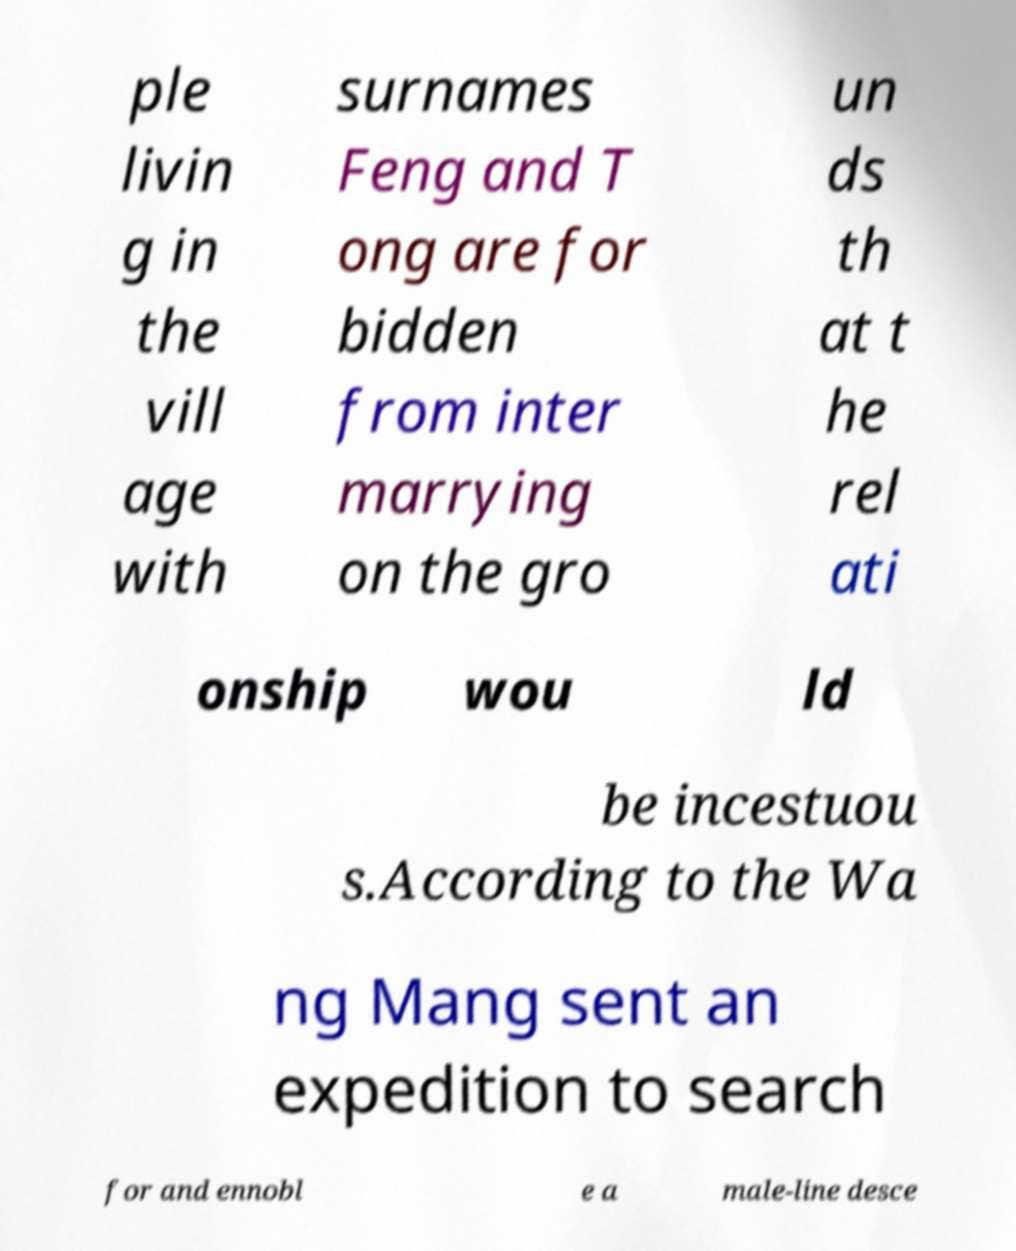Could you assist in decoding the text presented in this image and type it out clearly? ple livin g in the vill age with surnames Feng and T ong are for bidden from inter marrying on the gro un ds th at t he rel ati onship wou ld be incestuou s.According to the Wa ng Mang sent an expedition to search for and ennobl e a male-line desce 